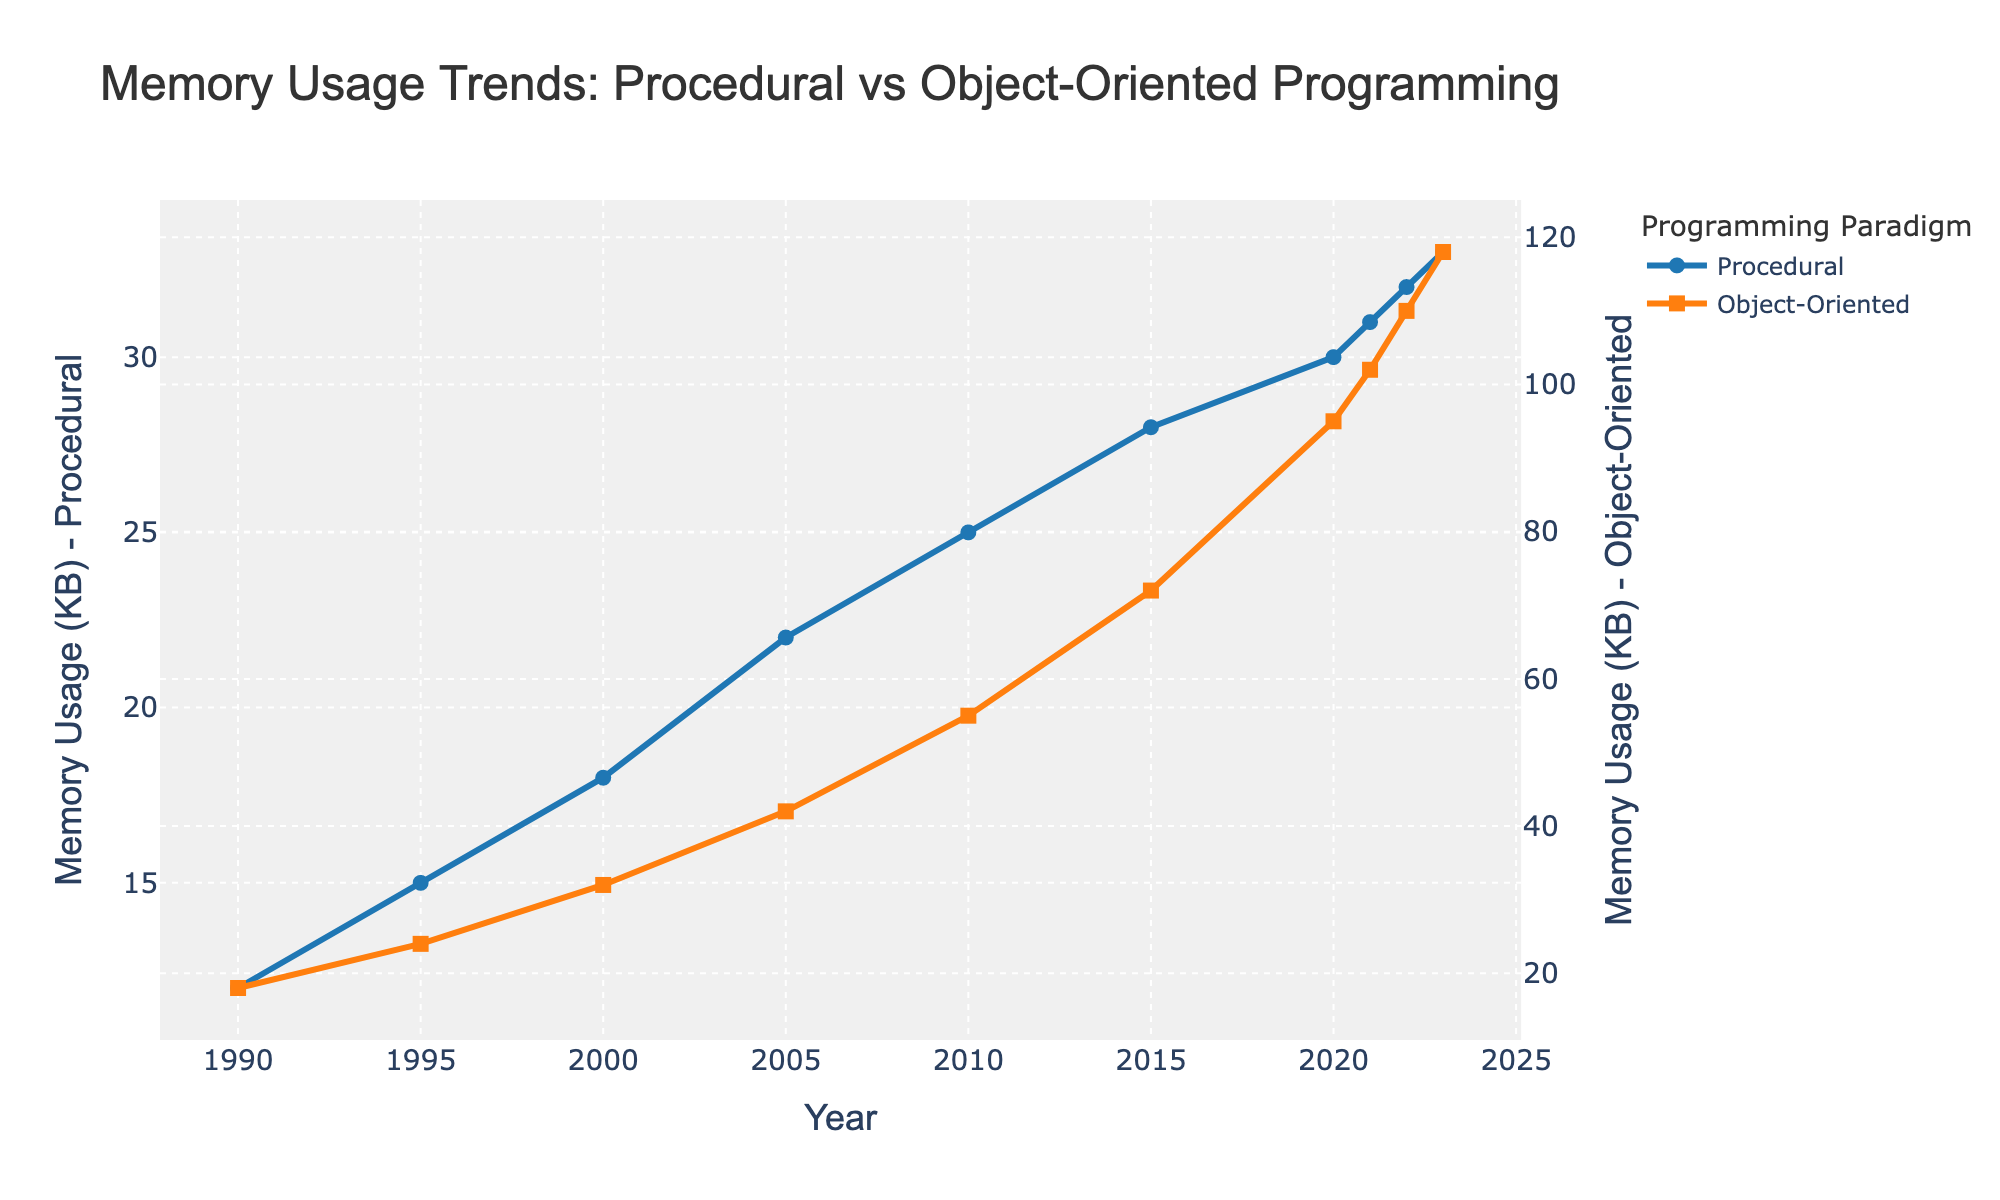What is the memory usage difference between Procedural and Object-Oriented programs in 2023? To find the difference, subtract the memory usage of Procedural programs in 2023 (33 KB) from the memory usage of Object-Oriented programs in 2023 (118 KB): 118 - 33 = 85 KB
Answer: 85 KB How has the memory usage of Object-Oriented programs changed from 2015 to 2023? The memory usage in 2015 is 72 KB and in 2023 it is 118 KB. The change is 118 - 72, which equals 46 KB.
Answer: Increased by 46 KB By what percentage has the memory usage of Procedural programs increased between 1990 and 2023? First, calculate the memory usage increase: 33 KB (2023) - 12 KB (1990) = 21 KB. Then, calculate the percentage increase: (21 KB / 12 KB) * 100 = 175%.
Answer: 175% Which programming paradigm shows a steeper increase in memory usage over time? By observing the gradients of the two lines, the Object-Oriented programming line is steeper than the Procedural one. This indicates that Object-Oriented programs show a steeper increase in memory usage.
Answer: Object-Oriented If you average the memory usage of Object-Oriented programs over the years, what do you get? Sum the memory usage values: 18 + 24 + 32 + 42 + 55 + 72 + 95 + 102 + 110 + 118 = 668 KB. There are 10 years, so the average is 668 / 10 = 66.8 KB.
Answer: 66.8 KB What is the trend of memory usage for Procedural programs from 1990 to 2023? The memory usage of Procedural programs steadily increases from 12 KB in 1990 to 33 KB in 2023.
Answer: Steadily increasing In which year did Object-Oriented programs' memory usage surpass 50 KB? Observing the trend, Object-Oriented memory usage surpasses 50 KB in 2010 when it reached 55 KB.
Answer: 2010 What's the difference in memory usage between Procedural programs in 2000 and 2023? The memory usage in 2000 was 18 KB, and in 2023 it was 33 KB. The difference is 33 - 18, equaling 15 KB.
Answer: 15 KB Compare the rate of increase in memory usage between the two paradigms from 2015 to 2023. For Procedural: Difference = 33 - 28 = 5 KB. For Object-Oriented: Difference = 118 - 72 = 46 KB. The rate of increase is greater for Object-Oriented programs.
Answer: Object-Oriented programs Based on the visual attributes, which line color represents Procedural programs in the chart? The chart uses blue for Procedural programs and orange for Object-Oriented programs, as indicated in the legend.
Answer: Blue 